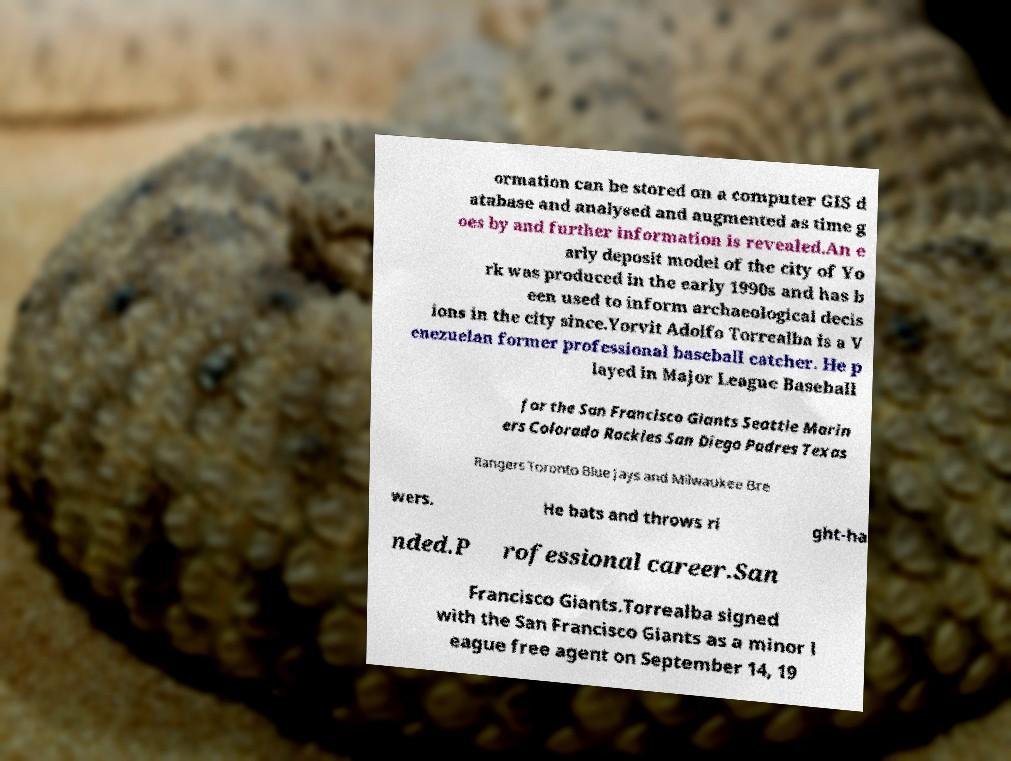Could you extract and type out the text from this image? ormation can be stored on a computer GIS d atabase and analysed and augmented as time g oes by and further information is revealed.An e arly deposit model of the city of Yo rk was produced in the early 1990s and has b een used to inform archaeological decis ions in the city since.Yorvit Adolfo Torrealba is a V enezuelan former professional baseball catcher. He p layed in Major League Baseball for the San Francisco Giants Seattle Marin ers Colorado Rockies San Diego Padres Texas Rangers Toronto Blue Jays and Milwaukee Bre wers. He bats and throws ri ght-ha nded.P rofessional career.San Francisco Giants.Torrealba signed with the San Francisco Giants as a minor l eague free agent on September 14, 19 